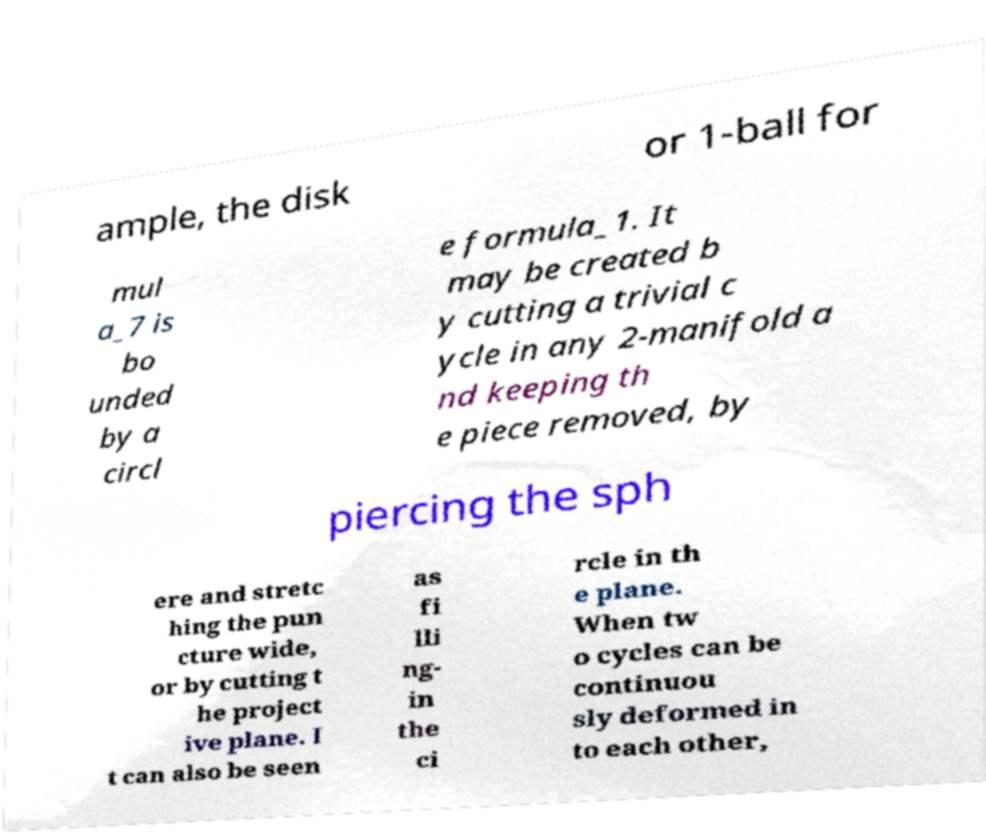Can you accurately transcribe the text from the provided image for me? ample, the disk or 1-ball for mul a_7 is bo unded by a circl e formula_1. It may be created b y cutting a trivial c ycle in any 2-manifold a nd keeping th e piece removed, by piercing the sph ere and stretc hing the pun cture wide, or by cutting t he project ive plane. I t can also be seen as fi lli ng- in the ci rcle in th e plane. When tw o cycles can be continuou sly deformed in to each other, 